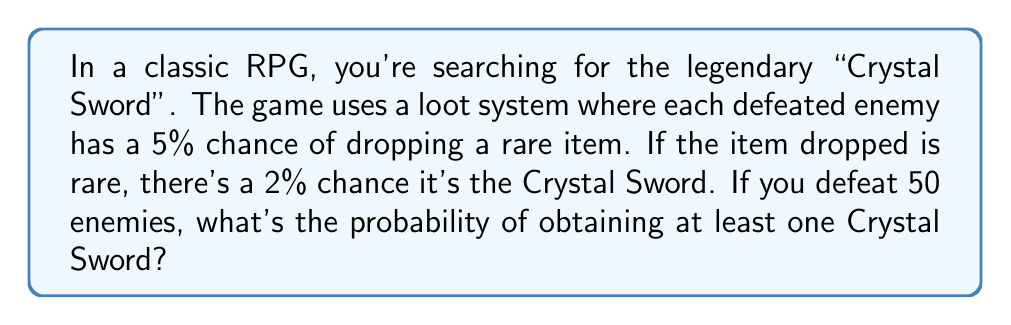Show me your answer to this math problem. Let's approach this step-by-step:

1) First, we need to calculate the probability of getting a Crystal Sword from a single enemy:
   
   $P(\text{Crystal Sword}) = P(\text{Rare}) \times P(\text{Crystal Sword | Rare})$
   $= 0.05 \times 0.02 = 0.001$ or 0.1%

2) Now, we need to find the probability of not getting a Crystal Sword from a single enemy:
   
   $P(\text{No Crystal Sword}) = 1 - P(\text{Crystal Sword}) = 1 - 0.001 = 0.999$ or 99.9%

3) For 50 enemies, we want the probability of getting at least one Crystal Sword. This is easier to calculate by first finding the probability of getting no Crystal Swords from all 50 enemies:

   $P(\text{No Crystal Sword in 50 enemies}) = (0.999)^{50}$

4) Therefore, the probability of getting at least one Crystal Sword is:

   $P(\text{At least one Crystal Sword}) = 1 - P(\text{No Crystal Sword in 50 enemies})$
   $= 1 - (0.999)^{50}$

5) Let's calculate this:

   $1 - (0.999)^{50} \approx 1 - 0.9512 = 0.0488$

6) Convert to a percentage:

   $0.0488 \times 100\% = 4.88\%$
Answer: The probability of obtaining at least one Crystal Sword after defeating 50 enemies is approximately 4.88%. 